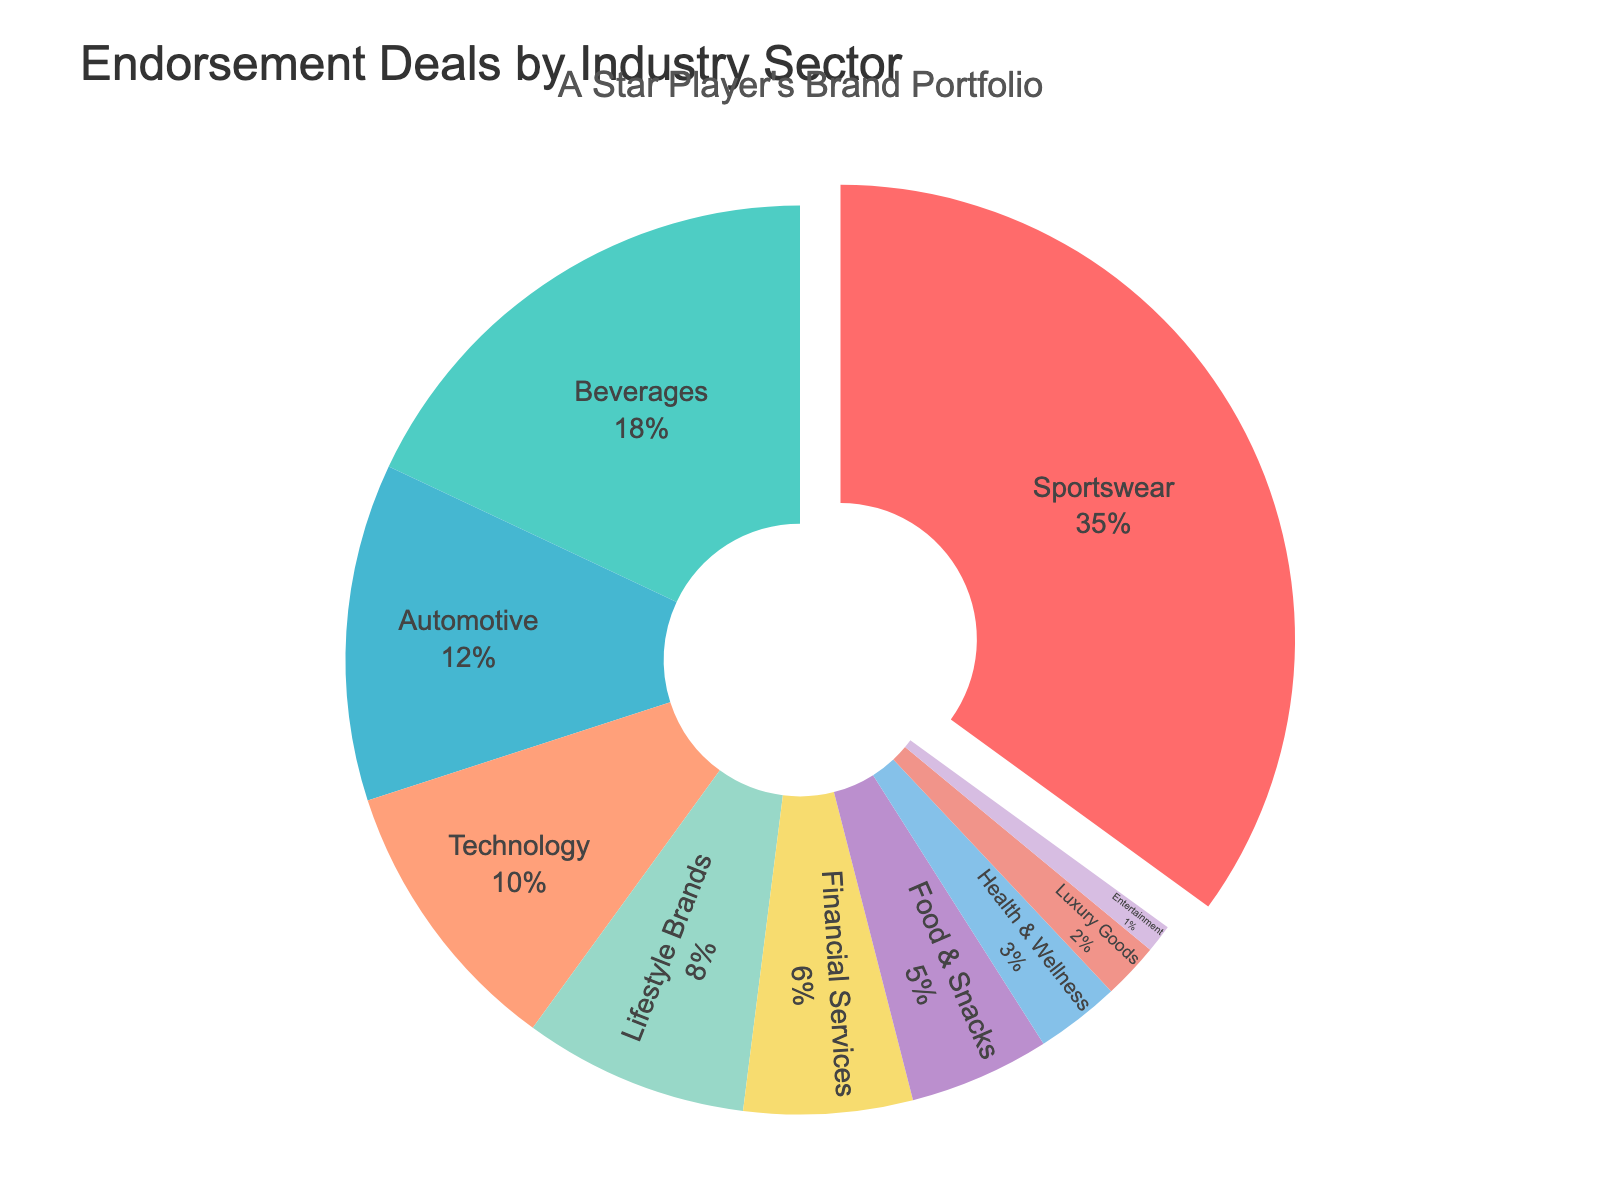Which industry holds the largest share in endorsement deals? The pie chart shows that the 'Sportswear' sector holds the largest segment of the chart.
Answer: Sportswear How much larger is the percentage of Sportswear endorsements compared to Automotive? The percentage for Sportswear is 35%, and for Automotive, it is 12%. Subtract 12 from 35 (35 - 12).
Answer: 23% What is the combined percentage of endorsements for Automotive, Technology, and Lifestyle Brands? Sum the percentages: Automotive (12%) + Technology (10%) + Lifestyle Brands (8%) = 12 + 10 + 8.
Answer: 30% Which sector has a higher endorsement percentage, Financial Services or Food & Snacks? The chart shows Financial Services at 6% and Food & Snacks at 5%. Since 6 is greater than 5, Financial Services has a higher percentage.
Answer: Financial Services Are there more endorsements in the Health & Wellness sector or the Luxury Goods sector? The chart shows 3% for Health & Wellness and 2% for Luxury Goods. Since 3% is greater than 2%, Health & Wellness has more endorsements.
Answer: Health & Wellness What is the total percentage of endorsements covered by the top two sectors? The top two sectors are Sportswear (35%) and Beverages (18%). Add these two percentages: 35 + 18.
Answer: 53% What percentage of the pie chart is not covered by Sportswear and Beverages? Sportswear is 35% and Beverages is 18%. Subtract their sum from 100%: 100 - (35 + 18).
Answer: 47% How many sectors have less than 10% of endorsements each? By examining the pie chart, sectors under 10% are Technology, Lifestyle Brands, Financial Services, Food & Snacks, Health & Wellness, Luxury Goods, and Entertainment. Count these sectors.
Answer: 7 Which sector is the smallest in terms of endorsement percentage? The smallest sector shown in the pie chart is Entertainment with 1%.
Answer: Entertainment What is the percentage difference between Financial Services endorsements and Health & Wellness endorsements? Financial Services is 6% and Health & Wellness is 3%. Subtract 3 from 6 (6 - 3).
Answer: 3% 